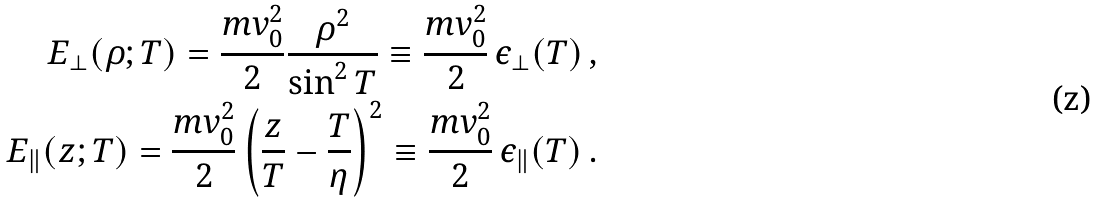Convert formula to latex. <formula><loc_0><loc_0><loc_500><loc_500>E _ { \perp } ( \rho ; T ) = \frac { m v _ { 0 } ^ { 2 } } 2 \frac { \rho ^ { 2 } } { \sin ^ { 2 } T } \equiv \frac { m v _ { 0 } ^ { 2 } } 2 \, \epsilon _ { \perp } ( T ) \, , \\ E _ { \| } ( z ; T ) = \frac { m v _ { 0 } ^ { 2 } } 2 \left ( \frac { z } { T } - \frac { T } { \eta } \right ) ^ { 2 } \equiv \frac { m v _ { 0 } ^ { 2 } } 2 \, \epsilon _ { \| } ( T ) \, .</formula> 